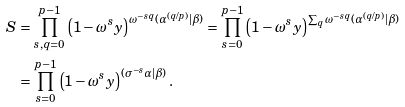<formula> <loc_0><loc_0><loc_500><loc_500>S & = \prod _ { s , q = 0 } ^ { p - 1 } \left ( 1 - \omega ^ { s } y \right ) ^ { \omega ^ { - s q } ( \alpha ^ { ( q / p ) } | \beta ) } = \prod _ { s = 0 } ^ { p - 1 } \left ( 1 - \omega ^ { s } y \right ) ^ { \sum _ { q } \omega ^ { - s q } ( \alpha ^ { ( q / p ) } | \beta ) } \\ & = \prod _ { s = 0 } ^ { p - 1 } \left ( 1 - \omega ^ { s } y \right ) ^ { ( \sigma ^ { - s } \alpha | \beta ) } .</formula> 